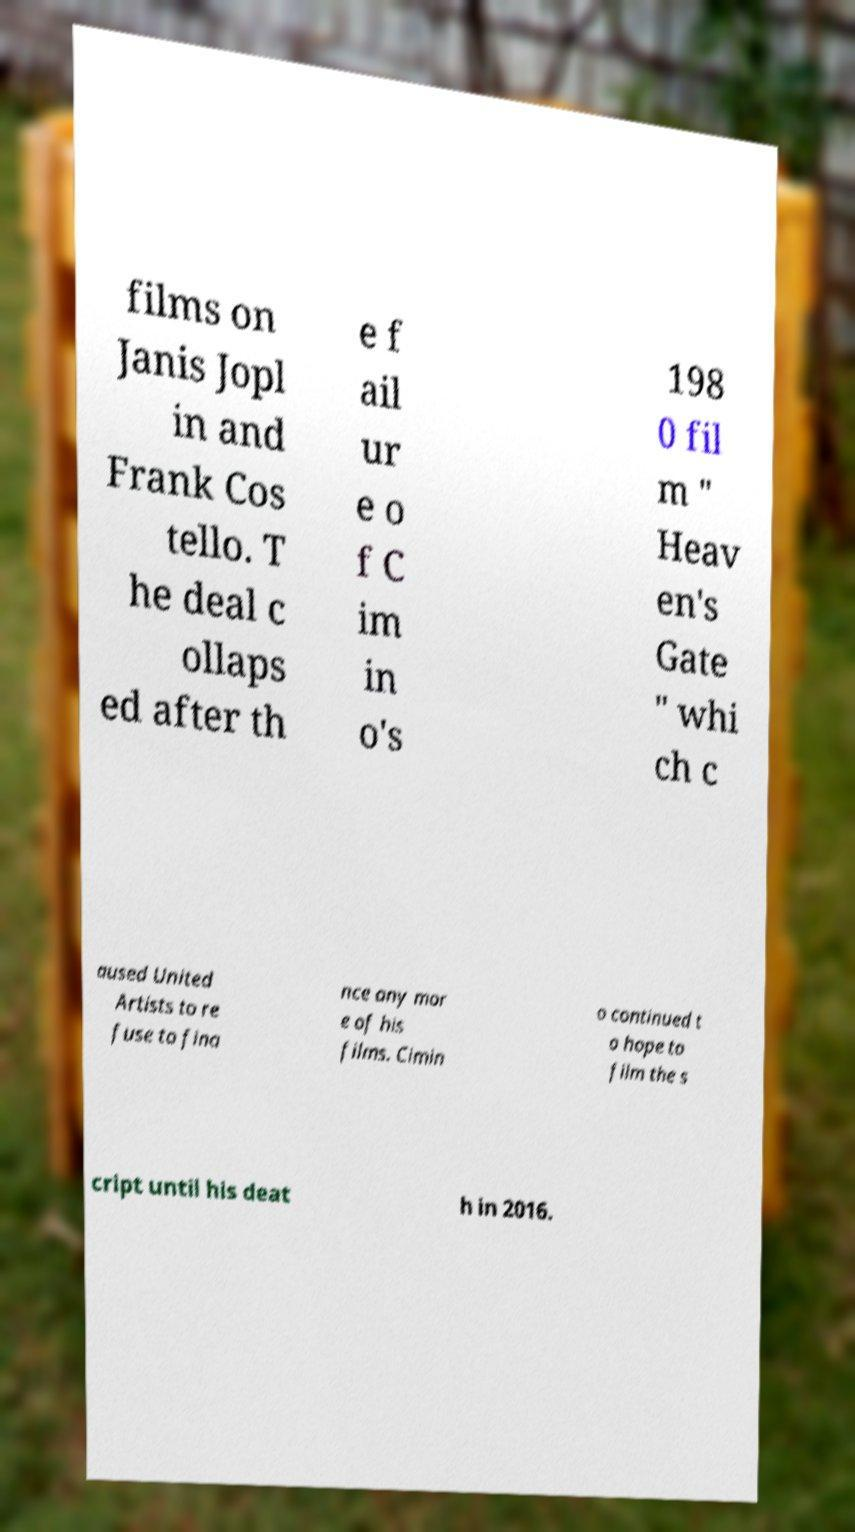Could you extract and type out the text from this image? films on Janis Jopl in and Frank Cos tello. T he deal c ollaps ed after th e f ail ur e o f C im in o's 198 0 fil m " Heav en's Gate " whi ch c aused United Artists to re fuse to fina nce any mor e of his films. Cimin o continued t o hope to film the s cript until his deat h in 2016. 